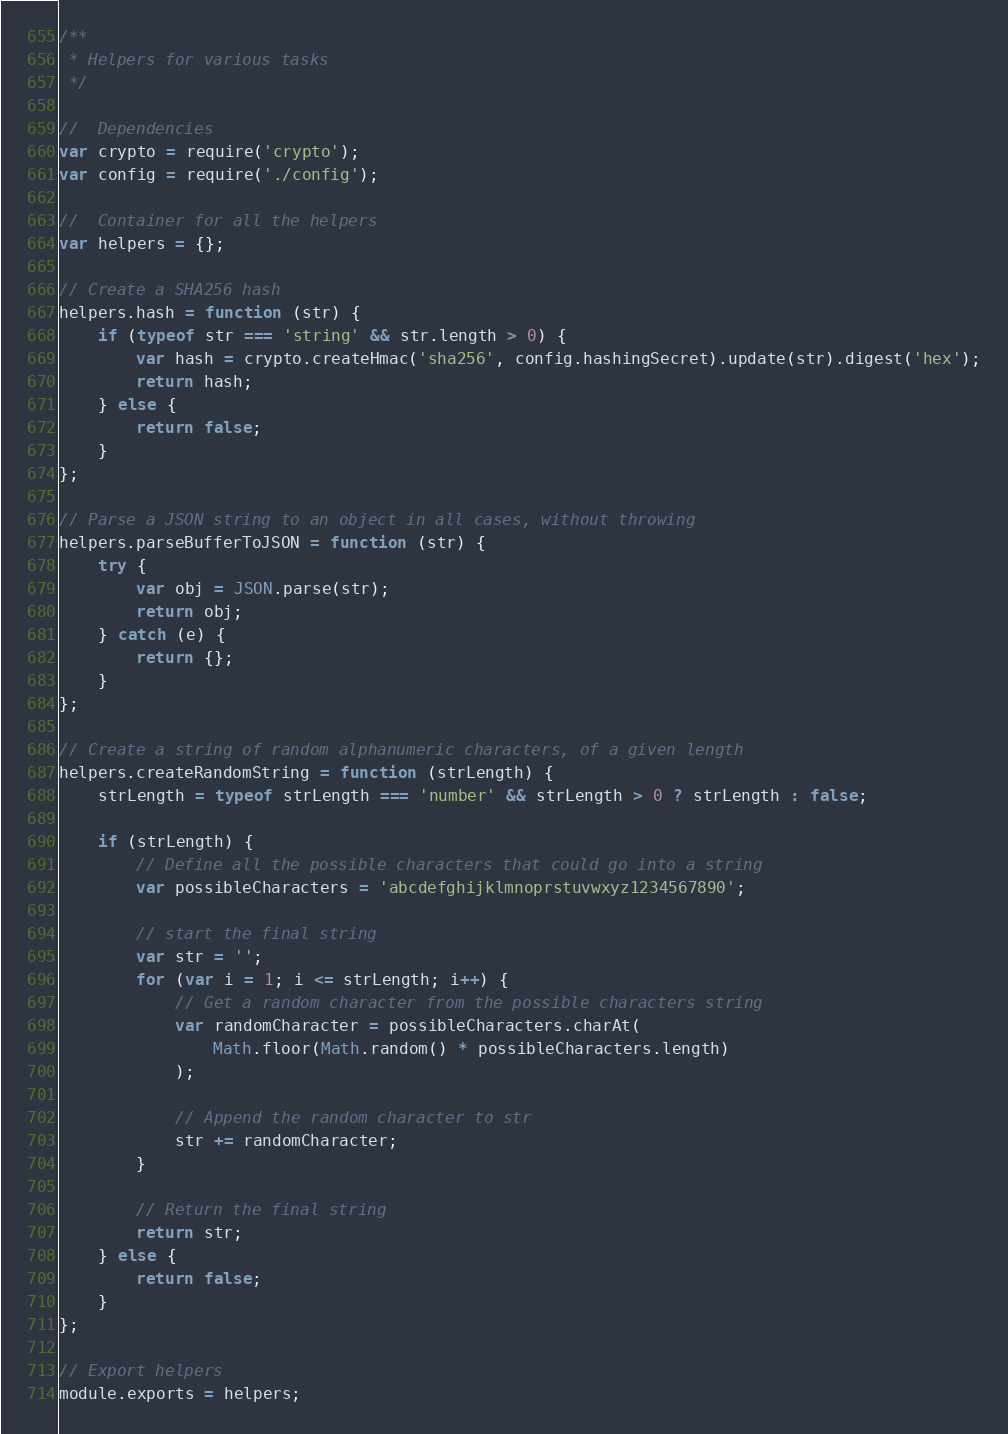<code> <loc_0><loc_0><loc_500><loc_500><_JavaScript_>/**
 * Helpers for various tasks
 */

//  Dependencies
var crypto = require('crypto');
var config = require('./config');

//  Container for all the helpers
var helpers = {};

// Create a SHA256 hash
helpers.hash = function (str) {
    if (typeof str === 'string' && str.length > 0) {
        var hash = crypto.createHmac('sha256', config.hashingSecret).update(str).digest('hex');
        return hash;
    } else {
        return false;
    }
};

// Parse a JSON string to an object in all cases, without throwing
helpers.parseBufferToJSON = function (str) {
    try {
        var obj = JSON.parse(str);
        return obj;
    } catch (e) {
        return {};
    }
};

// Create a string of random alphanumeric characters, of a given length
helpers.createRandomString = function (strLength) {
    strLength = typeof strLength === 'number' && strLength > 0 ? strLength : false;

    if (strLength) {
        // Define all the possible characters that could go into a string
        var possibleCharacters = 'abcdefghijklmnoprstuvwxyz1234567890';

        // start the final string
        var str = '';
        for (var i = 1; i <= strLength; i++) {
            // Get a random character from the possible characters string
            var randomCharacter = possibleCharacters.charAt(
                Math.floor(Math.random() * possibleCharacters.length)
            );

            // Append the random character to str
            str += randomCharacter;
        }

        // Return the final string
        return str;
    } else {
        return false;
    }
};

// Export helpers
module.exports = helpers;
</code> 